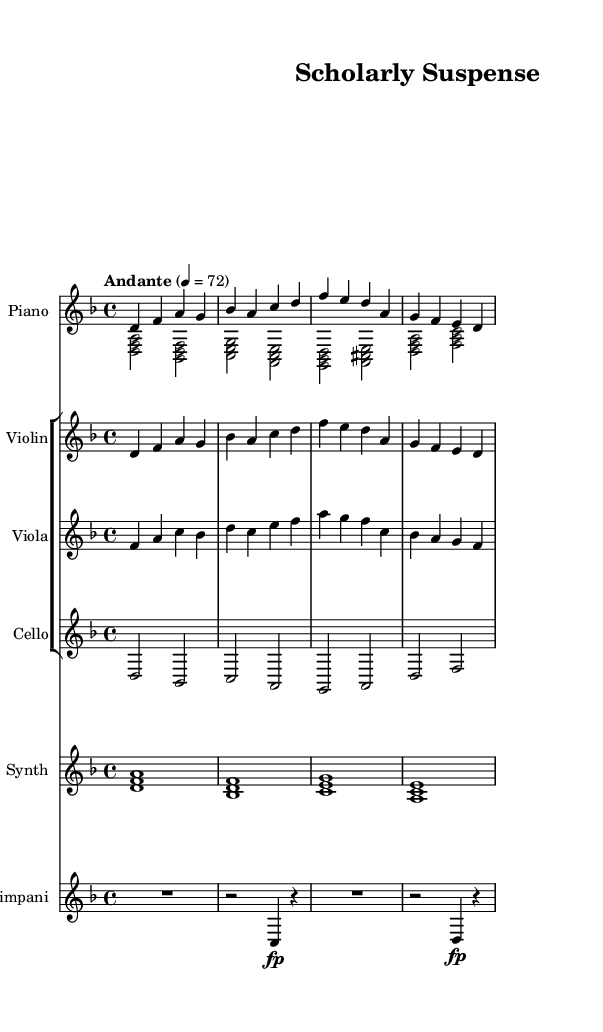What is the key signature of this music? The key signature is indicated as two flats, representing the notes B flat and E flat, which is characteristic of the key of D minor.
Answer: D minor What is the time signature of the music? The time signature appears at the beginning of the score and is written as 4 over 4, indicating four quarter-note beats in each measure.
Answer: 4/4 What is the tempo marking given in the score? The tempo marking is represented as "Andante" followed by a metronome marking of 72, suggesting a moderate walking pace.
Answer: Andante 4 = 72 How many measures are there in the melody section? The melody section encompasses eight measures as counted visually from the beginning to the end of that segment.
Answer: 8 Which instruments are included in the orchestral parts? The orchestral parts comprise a violin, viola, cello, and a synth pad layer, as listed in the staff designation.
Answer: Violin, viola, cello, synth pad What dynamics are indicated for the timpani part? The timpani part begins with a rest and displays a forte marking (fp) in measures two and four, highlighting an emphasis on those notes.
Answer: Forte What type of fusion is this piece categorized as? The piece is described as an ambient-orchestral fusion, which combines ambient textures with orchestral elements to create a specific atmosphere.
Answer: Ambient-orchestral fusion 